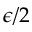Convert formula to latex. <formula><loc_0><loc_0><loc_500><loc_500>\epsilon / 2</formula> 